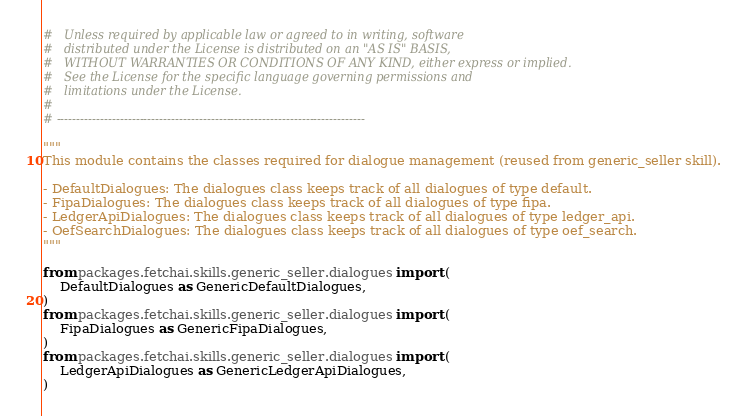Convert code to text. <code><loc_0><loc_0><loc_500><loc_500><_Python_>#   Unless required by applicable law or agreed to in writing, software
#   distributed under the License is distributed on an "AS IS" BASIS,
#   WITHOUT WARRANTIES OR CONDITIONS OF ANY KIND, either express or implied.
#   See the License for the specific language governing permissions and
#   limitations under the License.
#
# ------------------------------------------------------------------------------

"""
This module contains the classes required for dialogue management (reused from generic_seller skill).

- DefaultDialogues: The dialogues class keeps track of all dialogues of type default.
- FipaDialogues: The dialogues class keeps track of all dialogues of type fipa.
- LedgerApiDialogues: The dialogues class keeps track of all dialogues of type ledger_api.
- OefSearchDialogues: The dialogues class keeps track of all dialogues of type oef_search.
"""

from packages.fetchai.skills.generic_seller.dialogues import (
    DefaultDialogues as GenericDefaultDialogues,
)
from packages.fetchai.skills.generic_seller.dialogues import (
    FipaDialogues as GenericFipaDialogues,
)
from packages.fetchai.skills.generic_seller.dialogues import (
    LedgerApiDialogues as GenericLedgerApiDialogues,
)</code> 